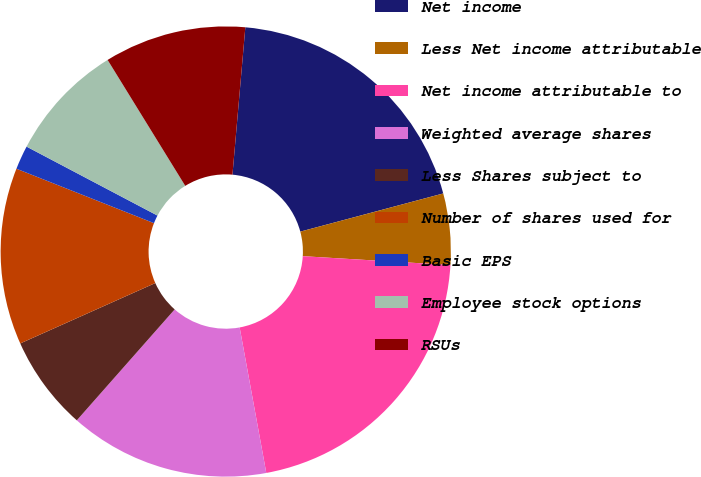Convert chart to OTSL. <chart><loc_0><loc_0><loc_500><loc_500><pie_chart><fcel>Net income<fcel>Less Net income attributable<fcel>Net income attributable to<fcel>Weighted average shares<fcel>Less Shares subject to<fcel>Number of shares used for<fcel>Basic EPS<fcel>Employee stock options<fcel>RSUs<nl><fcel>19.46%<fcel>5.11%<fcel>21.16%<fcel>14.39%<fcel>6.8%<fcel>12.69%<fcel>1.72%<fcel>8.49%<fcel>10.18%<nl></chart> 